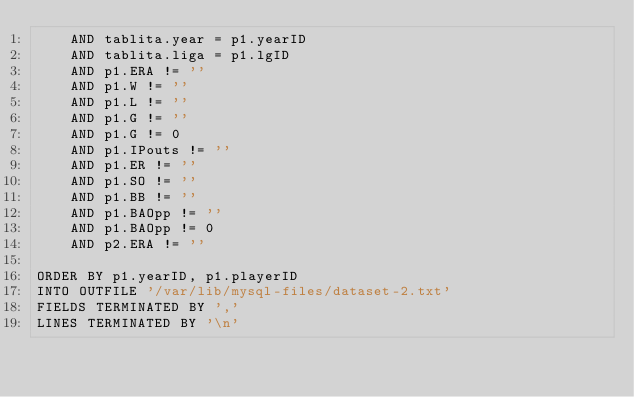Convert code to text. <code><loc_0><loc_0><loc_500><loc_500><_SQL_>	  AND tablita.year = p1.yearID
	  AND tablita.liga = p1.lgID
	  AND p1.ERA != ''
	  AND p1.W != ''
	  AND p1.L != ''
	  AND p1.G != ''
	  AND p1.G != 0
	  AND p1.IPouts != ''
	  AND p1.ER != ''
	  AND p1.SO != ''
	  AND p1.BB != ''
	  AND p1.BAOpp != ''
	  AND p1.BAOpp != 0
	  AND p2.ERA != ''

ORDER BY p1.yearID, p1.playerID
INTO OUTFILE '/var/lib/mysql-files/dataset-2.txt'
FIELDS TERMINATED BY ','
LINES TERMINATED BY '\n'
</code> 